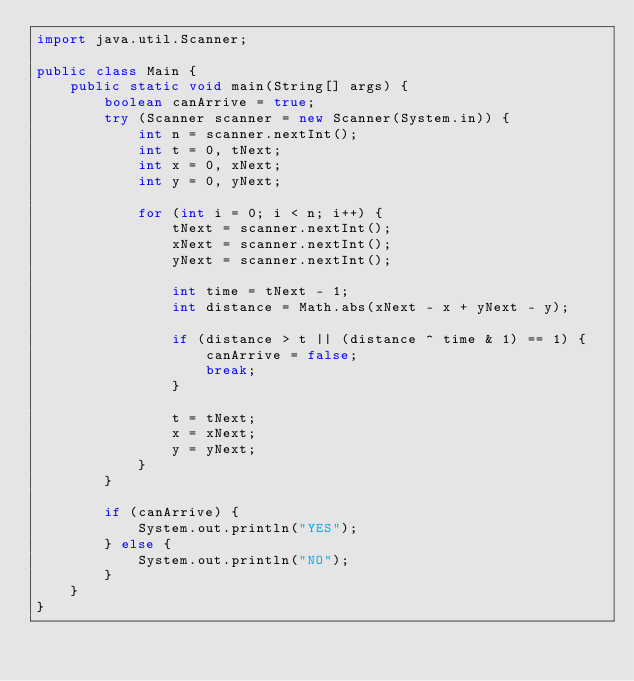<code> <loc_0><loc_0><loc_500><loc_500><_Java_>import java.util.Scanner;

public class Main {
	public static void main(String[] args) {
		boolean canArrive = true;
		try (Scanner scanner = new Scanner(System.in)) {
			int n = scanner.nextInt();
			int t = 0, tNext;
			int x = 0, xNext;
			int y = 0, yNext;

			for (int i = 0; i < n; i++) {
				tNext = scanner.nextInt();
				xNext = scanner.nextInt();
				yNext = scanner.nextInt();

				int time = tNext - 1;
				int distance = Math.abs(xNext - x + yNext - y);

				if (distance > t || (distance ^ time & 1) == 1) {
					canArrive = false;
					break;
				}

				t = tNext;
				x = xNext;
				y = yNext;
			}
		}

		if (canArrive) {
			System.out.println("YES");
		} else {
			System.out.println("NO");
		}
	}
}</code> 